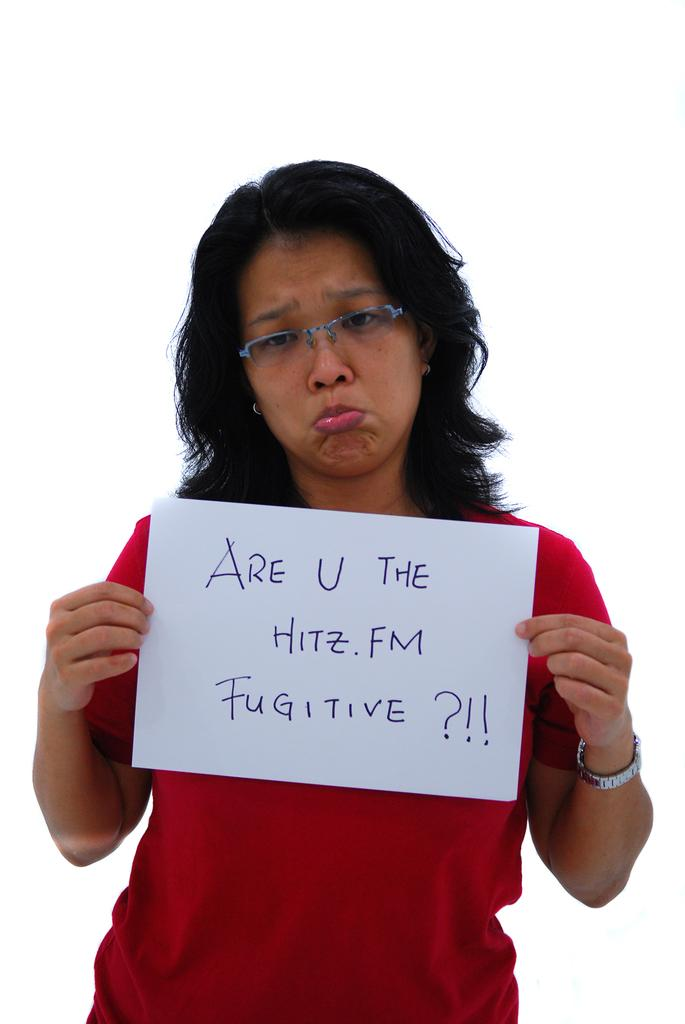<image>
Summarize the visual content of the image. A woman frowning and holding a sign asking about 'HITZ.FM FUGITIVES.' 